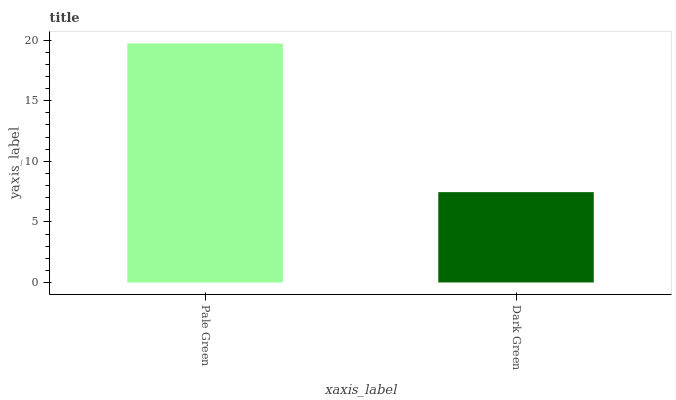Is Dark Green the maximum?
Answer yes or no. No. Is Pale Green greater than Dark Green?
Answer yes or no. Yes. Is Dark Green less than Pale Green?
Answer yes or no. Yes. Is Dark Green greater than Pale Green?
Answer yes or no. No. Is Pale Green less than Dark Green?
Answer yes or no. No. Is Pale Green the high median?
Answer yes or no. Yes. Is Dark Green the low median?
Answer yes or no. Yes. Is Dark Green the high median?
Answer yes or no. No. Is Pale Green the low median?
Answer yes or no. No. 